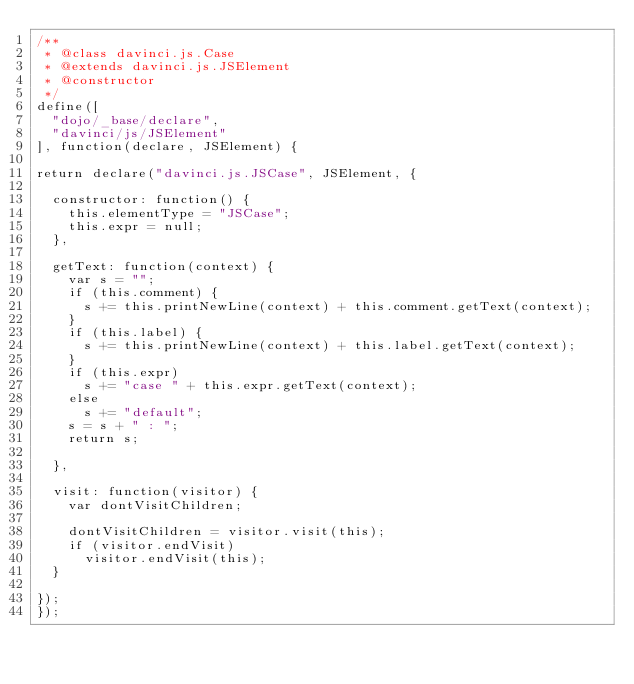Convert code to text. <code><loc_0><loc_0><loc_500><loc_500><_JavaScript_>/**
 * @class davinci.js.Case
 * @extends davinci.js.JSElement
 * @constructor
 */
define([
	"dojo/_base/declare",
	"davinci/js/JSElement"
], function(declare, JSElement) {

return declare("davinci.js.JSCase", JSElement, {

	constructor: function() {
		this.elementType = "JSCase";
		this.expr = null;
	},

	getText: function(context) {
		var s = "";
		if (this.comment) {
			s += this.printNewLine(context) + this.comment.getText(context);
		}
		if (this.label) {
			s += this.printNewLine(context) + this.label.getText(context);
		}
		if (this.expr)
			s += "case " + this.expr.getText(context);
		else
			s += "default";
		s = s + " : ";
		return s;

	},

	visit: function(visitor) {
		var dontVisitChildren;

		dontVisitChildren = visitor.visit(this);
		if (visitor.endVisit)
			visitor.endVisit(this);
	}

});
});</code> 